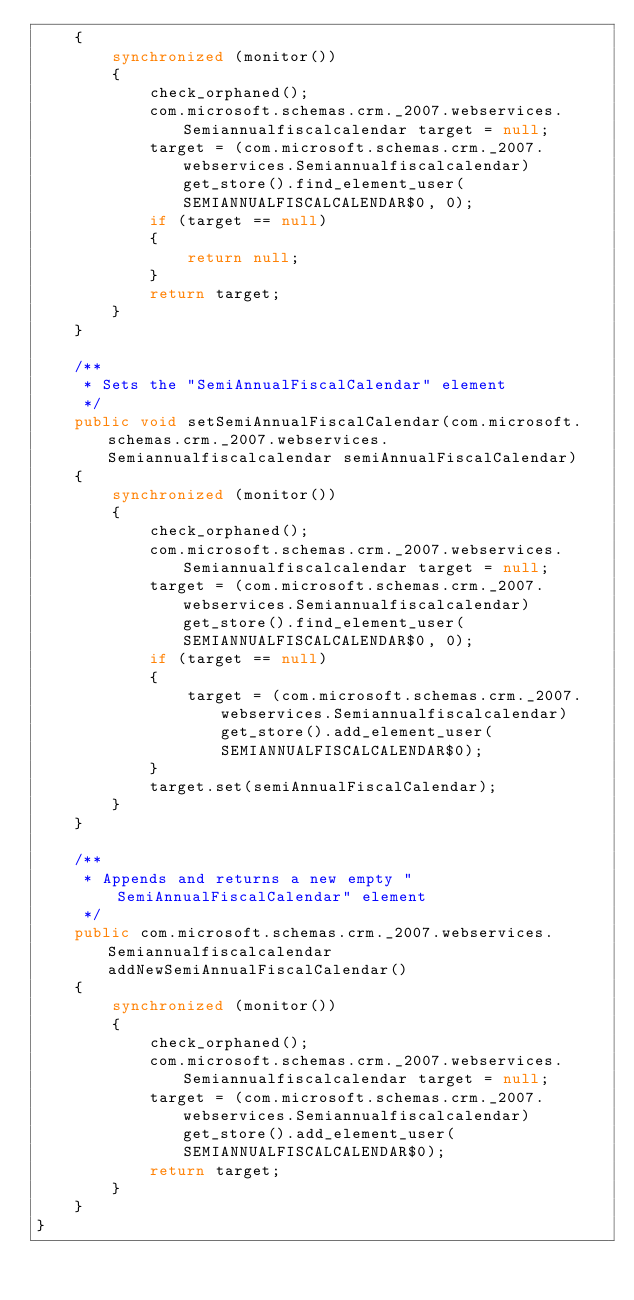Convert code to text. <code><loc_0><loc_0><loc_500><loc_500><_Java_>    {
        synchronized (monitor())
        {
            check_orphaned();
            com.microsoft.schemas.crm._2007.webservices.Semiannualfiscalcalendar target = null;
            target = (com.microsoft.schemas.crm._2007.webservices.Semiannualfiscalcalendar)get_store().find_element_user(SEMIANNUALFISCALCALENDAR$0, 0);
            if (target == null)
            {
                return null;
            }
            return target;
        }
    }
    
    /**
     * Sets the "SemiAnnualFiscalCalendar" element
     */
    public void setSemiAnnualFiscalCalendar(com.microsoft.schemas.crm._2007.webservices.Semiannualfiscalcalendar semiAnnualFiscalCalendar)
    {
        synchronized (monitor())
        {
            check_orphaned();
            com.microsoft.schemas.crm._2007.webservices.Semiannualfiscalcalendar target = null;
            target = (com.microsoft.schemas.crm._2007.webservices.Semiannualfiscalcalendar)get_store().find_element_user(SEMIANNUALFISCALCALENDAR$0, 0);
            if (target == null)
            {
                target = (com.microsoft.schemas.crm._2007.webservices.Semiannualfiscalcalendar)get_store().add_element_user(SEMIANNUALFISCALCALENDAR$0);
            }
            target.set(semiAnnualFiscalCalendar);
        }
    }
    
    /**
     * Appends and returns a new empty "SemiAnnualFiscalCalendar" element
     */
    public com.microsoft.schemas.crm._2007.webservices.Semiannualfiscalcalendar addNewSemiAnnualFiscalCalendar()
    {
        synchronized (monitor())
        {
            check_orphaned();
            com.microsoft.schemas.crm._2007.webservices.Semiannualfiscalcalendar target = null;
            target = (com.microsoft.schemas.crm._2007.webservices.Semiannualfiscalcalendar)get_store().add_element_user(SEMIANNUALFISCALCALENDAR$0);
            return target;
        }
    }
}
</code> 